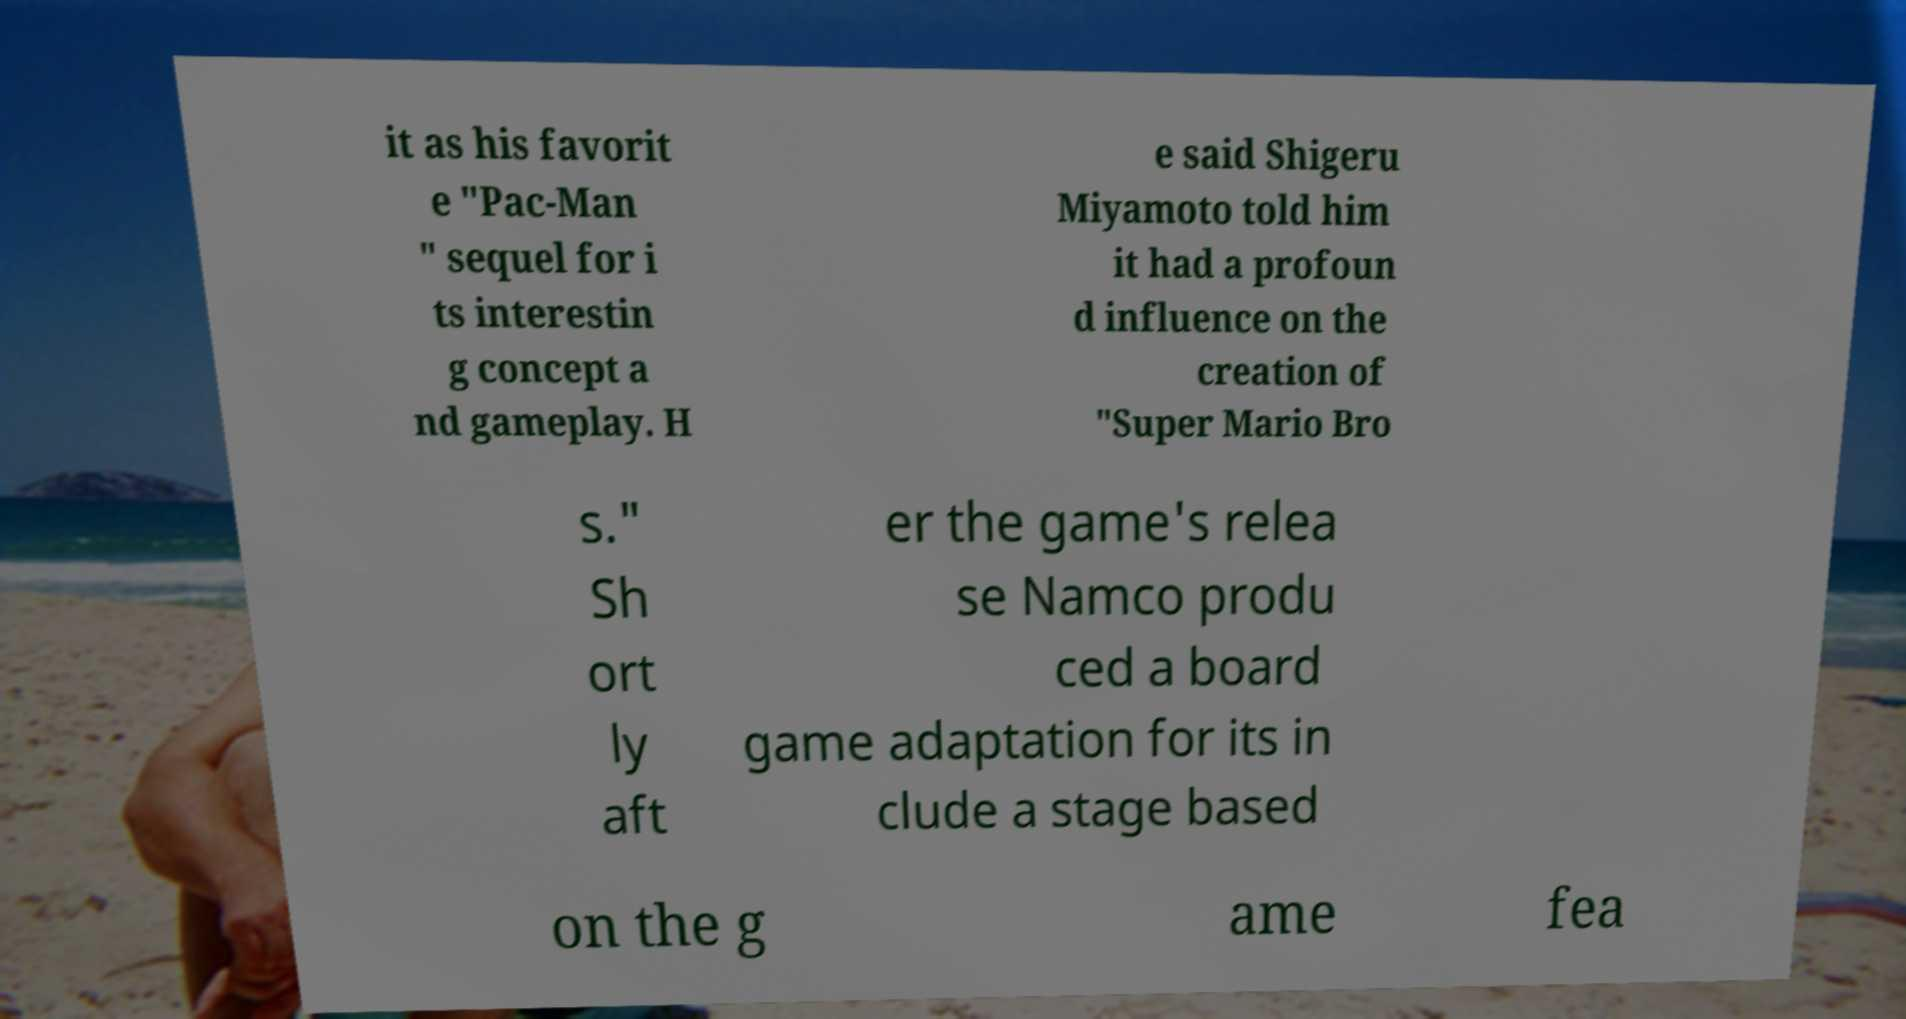Please read and relay the text visible in this image. What does it say? it as his favorit e "Pac-Man " sequel for i ts interestin g concept a nd gameplay. H e said Shigeru Miyamoto told him it had a profoun d influence on the creation of "Super Mario Bro s." Sh ort ly aft er the game's relea se Namco produ ced a board game adaptation for its in clude a stage based on the g ame fea 